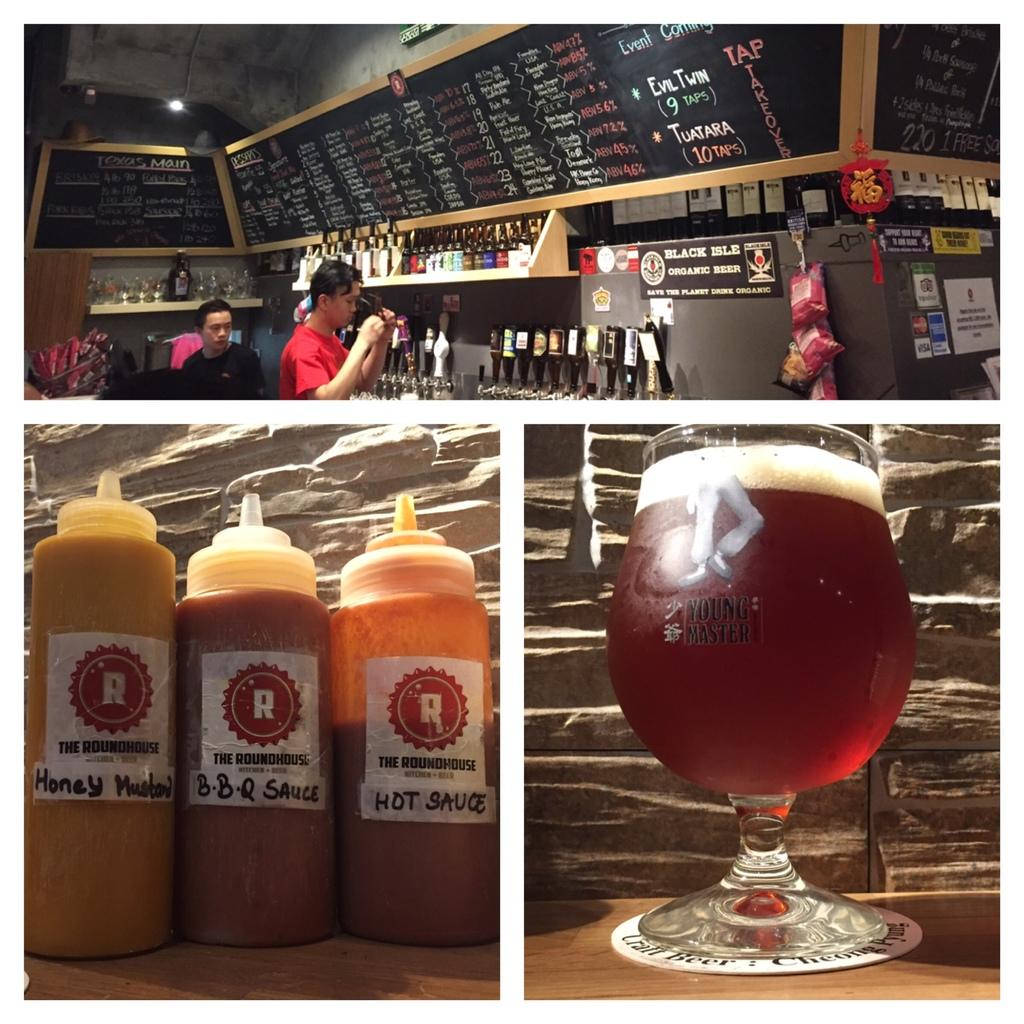<image>
Create a compact narrative representing the image presented. Three bbq sauces are in a row, the left most one is honey mustard. 